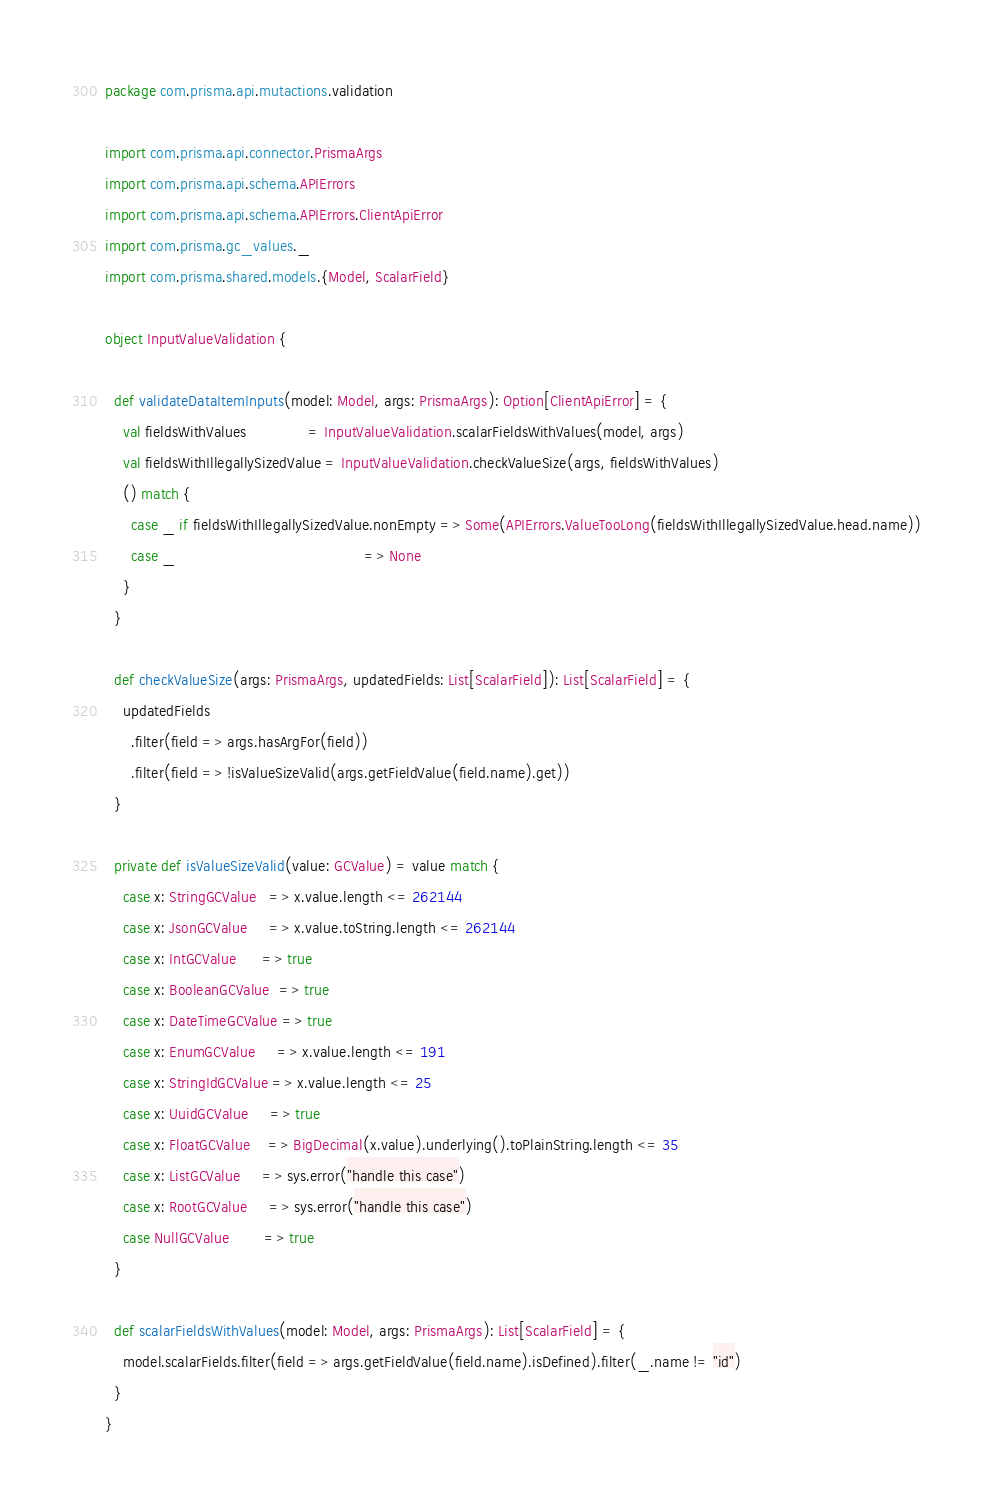<code> <loc_0><loc_0><loc_500><loc_500><_Scala_>package com.prisma.api.mutactions.validation

import com.prisma.api.connector.PrismaArgs
import com.prisma.api.schema.APIErrors
import com.prisma.api.schema.APIErrors.ClientApiError
import com.prisma.gc_values._
import com.prisma.shared.models.{Model, ScalarField}

object InputValueValidation {

  def validateDataItemInputs(model: Model, args: PrismaArgs): Option[ClientApiError] = {
    val fieldsWithValues              = InputValueValidation.scalarFieldsWithValues(model, args)
    val fieldsWithIllegallySizedValue = InputValueValidation.checkValueSize(args, fieldsWithValues)
    () match {
      case _ if fieldsWithIllegallySizedValue.nonEmpty => Some(APIErrors.ValueTooLong(fieldsWithIllegallySizedValue.head.name))
      case _                                           => None
    }
  }

  def checkValueSize(args: PrismaArgs, updatedFields: List[ScalarField]): List[ScalarField] = {
    updatedFields
      .filter(field => args.hasArgFor(field))
      .filter(field => !isValueSizeValid(args.getFieldValue(field.name).get))
  }

  private def isValueSizeValid(value: GCValue) = value match {
    case x: StringGCValue   => x.value.length <= 262144
    case x: JsonGCValue     => x.value.toString.length <= 262144
    case x: IntGCValue      => true
    case x: BooleanGCValue  => true
    case x: DateTimeGCValue => true
    case x: EnumGCValue     => x.value.length <= 191
    case x: StringIdGCValue => x.value.length <= 25
    case x: UuidGCValue     => true
    case x: FloatGCValue    => BigDecimal(x.value).underlying().toPlainString.length <= 35
    case x: ListGCValue     => sys.error("handle this case")
    case x: RootGCValue     => sys.error("handle this case")
    case NullGCValue        => true
  }

  def scalarFieldsWithValues(model: Model, args: PrismaArgs): List[ScalarField] = {
    model.scalarFields.filter(field => args.getFieldValue(field.name).isDefined).filter(_.name != "id")
  }
}
</code> 